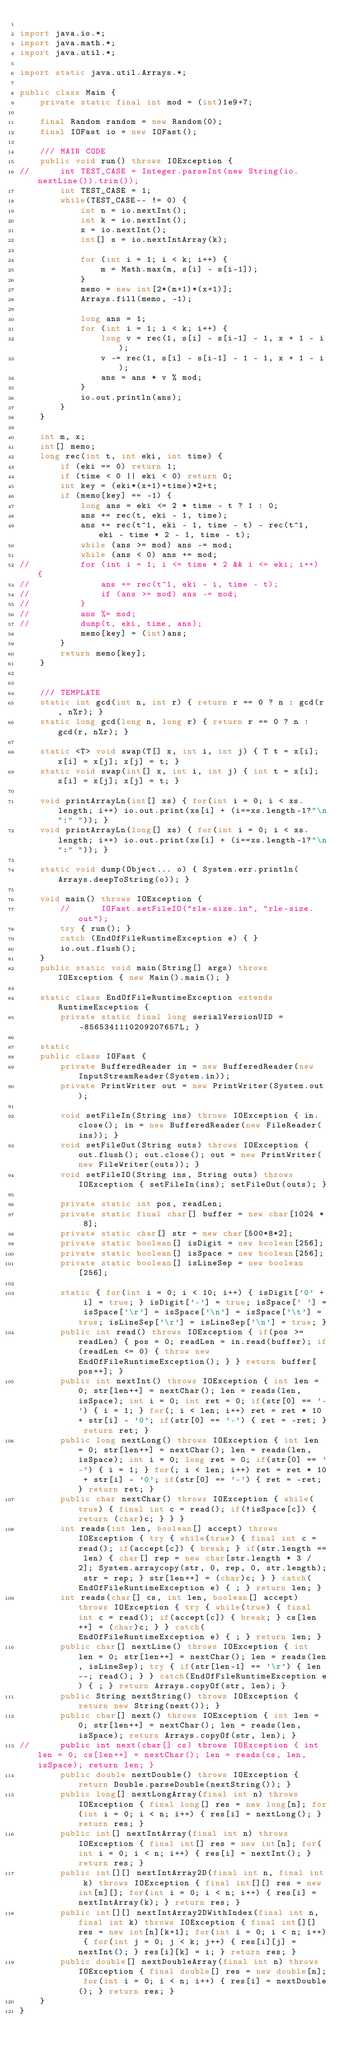Convert code to text. <code><loc_0><loc_0><loc_500><loc_500><_Java_>
import java.io.*;
import java.math.*;
import java.util.*;

import static java.util.Arrays.*;

public class Main {
	private static final int mod = (int)1e9+7;

	final Random random = new Random(0);
	final IOFast io = new IOFast();

	/// MAIN CODE
	public void run() throws IOException {
//		int TEST_CASE = Integer.parseInt(new String(io.nextLine()).trim());
		int TEST_CASE = 1;
		while(TEST_CASE-- != 0) {
			int n = io.nextInt();
			int k = io.nextInt();
			x = io.nextInt();
			int[] s = io.nextIntArray(k);
			
			for (int i = 1; i < k; i++) {
				m = Math.max(m, s[i] - s[i-1]);
			}
			memo = new int[2*(m+1)*(x+1)];
			Arrays.fill(memo, -1);
			
			long ans = 1;
			for (int i = 1; i < k; i++) {
				long v = rec(1, s[i] - s[i-1] - 1, x + 1 - i);
				v -= rec(1, s[i] - s[i-1] - 1 - 1, x + 1 - i);
				ans = ans * v % mod;
			}
			io.out.println(ans);
		}
	}

	int m, x;
	int[] memo;
	long rec(int t, int eki, int time) {
		if (eki == 0) return 1;
		if (time < 0 || eki < 0) return 0;
		int key = (eki*(x+1)+time)*2+t;
		if (memo[key] == -1) {
			long ans = eki <= 2 * time - t ? 1 : 0;
			ans += rec(t, eki - 1, time);
			ans += rec(t^1, eki - 1, time - t) - rec(t^1, eki - time * 2 - 1, time - t);
			while (ans >= mod) ans -= mod;
			while (ans < 0) ans += mod;
//			for (int i = 1; i <= time * 2 && i <= eki; i++) {
//				ans += rec(t^1, eki - i, time - t);
//				if (ans >= mod) ans -= mod;
//			}
//			ans %= mod;
//			dump(t, eki, time, ans);
			memo[key] = (int)ans;
		}
		return memo[key];
	}
	
	
	/// TEMPLATE
	static int gcd(int n, int r) { return r == 0 ? n : gcd(r, n%r); }
	static long gcd(long n, long r) { return r == 0 ? n : gcd(r, n%r); }
	
	static <T> void swap(T[] x, int i, int j) { T t = x[i]; x[i] = x[j]; x[j] = t; }
	static void swap(int[] x, int i, int j) { int t = x[i]; x[i] = x[j]; x[j] = t; }

	void printArrayLn(int[] xs) { for(int i = 0; i < xs.length; i++) io.out.print(xs[i] + (i==xs.length-1?"\n":" ")); }
	void printArrayLn(long[] xs) { for(int i = 0; i < xs.length; i++) io.out.print(xs[i] + (i==xs.length-1?"\n":" ")); }
	
	static void dump(Object... o) { System.err.println(Arrays.deepToString(o)); } 
	
	void main() throws IOException {
		//		IOFast.setFileIO("rle-size.in", "rle-size.out");
		try { run(); }
		catch (EndOfFileRuntimeException e) { }
		io.out.flush();
	}
	public static void main(String[] args) throws IOException { new Main().main(); }
	
	static class EndOfFileRuntimeException extends RuntimeException {
		private static final long serialVersionUID = -8565341110209207657L; }

	static
	public class IOFast {
		private BufferedReader in = new BufferedReader(new InputStreamReader(System.in));
		private PrintWriter out = new PrintWriter(System.out);

		void setFileIn(String ins) throws IOException { in.close(); in = new BufferedReader(new FileReader(ins)); }
		void setFileOut(String outs) throws IOException { out.flush(); out.close(); out = new PrintWriter(new FileWriter(outs)); }
		void setFileIO(String ins, String outs) throws IOException { setFileIn(ins); setFileOut(outs); }

		private static int pos, readLen;
		private static final char[] buffer = new char[1024 * 8];
		private static char[] str = new char[500*8*2];
		private static boolean[] isDigit = new boolean[256];
		private static boolean[] isSpace = new boolean[256];
		private static boolean[] isLineSep = new boolean[256];

		static { for(int i = 0; i < 10; i++) { isDigit['0' + i] = true; } isDigit['-'] = true; isSpace[' '] = isSpace['\r'] = isSpace['\n'] = isSpace['\t'] = true; isLineSep['\r'] = isLineSep['\n'] = true; }
		public int read() throws IOException { if(pos >= readLen) { pos = 0; readLen = in.read(buffer); if(readLen <= 0) { throw new EndOfFileRuntimeException(); } } return buffer[pos++]; }
		public int nextInt() throws IOException { int len = 0; str[len++] = nextChar(); len = reads(len, isSpace); int i = 0; int ret = 0; if(str[0] == '-') { i = 1; } for(; i < len; i++) ret = ret * 10 + str[i] - '0'; if(str[0] == '-') { ret = -ret; } return ret; }
		public long nextLong() throws IOException { int len = 0; str[len++] = nextChar(); len = reads(len, isSpace); int i = 0; long ret = 0; if(str[0] == '-') { i = 1; } for(; i < len; i++) ret = ret * 10 + str[i] - '0'; if(str[0] == '-') { ret = -ret; } return ret; }
		public char nextChar() throws IOException { while(true) { final int c = read(); if(!isSpace[c]) { return (char)c; } } }
		int reads(int len, boolean[] accept) throws IOException { try { while(true) { final int c = read(); if(accept[c]) { break; } if(str.length == len) { char[] rep = new char[str.length * 3 / 2]; System.arraycopy(str, 0, rep, 0, str.length); str = rep; } str[len++] = (char)c; } } catch(EndOfFileRuntimeException e) { ; } return len; }
		int reads(char[] cs, int len, boolean[] accept) throws IOException { try { while(true) { final int c = read(); if(accept[c]) { break; } cs[len++] = (char)c; } } catch(EndOfFileRuntimeException e) { ; } return len; }
		public char[] nextLine() throws IOException { int len = 0; str[len++] = nextChar(); len = reads(len, isLineSep); try { if(str[len-1] == '\r') { len--; read(); } } catch(EndOfFileRuntimeException e) { ; } return Arrays.copyOf(str, len); }
		public String nextString() throws IOException { return new String(next()); }
		public char[] next() throws IOException { int len = 0; str[len++] = nextChar(); len = reads(len, isSpace); return Arrays.copyOf(str, len); }
//		public int next(char[] cs) throws IOException { int len = 0; cs[len++] = nextChar(); len = reads(cs, len, isSpace); return len; }
		public double nextDouble() throws IOException { return Double.parseDouble(nextString()); }
		public long[] nextLongArray(final int n) throws IOException { final long[] res = new long[n]; for(int i = 0; i < n; i++) { res[i] = nextLong(); } return res; }
		public int[] nextIntArray(final int n) throws IOException { final int[] res = new int[n]; for(int i = 0; i < n; i++) { res[i] = nextInt(); } return res; }
		public int[][] nextIntArray2D(final int n, final int k) throws IOException { final int[][] res = new int[n][]; for(int i = 0; i < n; i++) { res[i] = nextIntArray(k); } return res; }
		public int[][] nextIntArray2DWithIndex(final int n, final int k) throws IOException { final int[][] res = new int[n][k+1]; for(int i = 0; i < n; i++) { for(int j = 0; j < k; j++) { res[i][j] = nextInt(); } res[i][k] = i; } return res; }
		public double[] nextDoubleArray(final int n) throws IOException { final double[] res = new double[n]; for(int i = 0; i < n; i++) { res[i] = nextDouble(); } return res; }
	}
}
</code> 